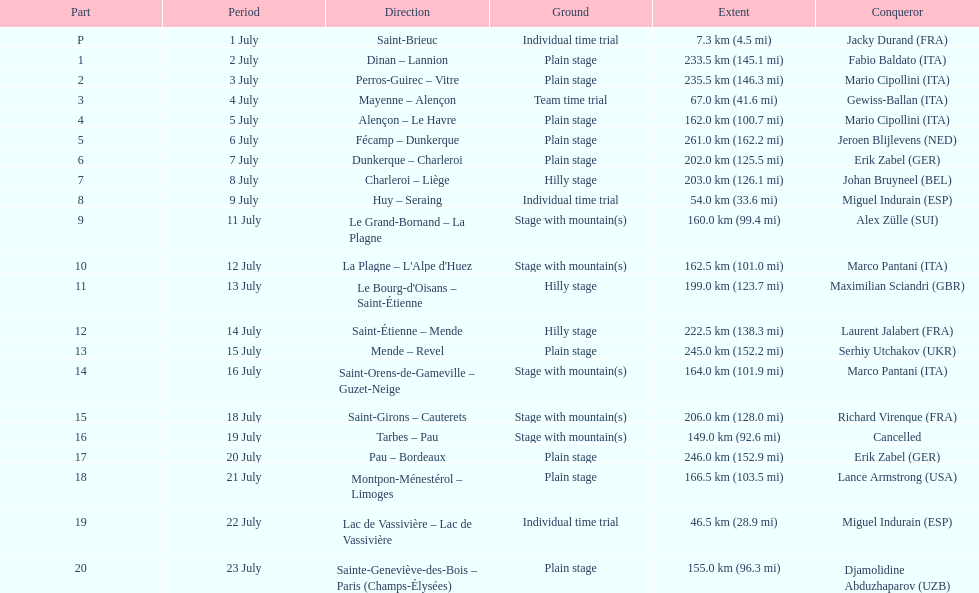Would you mind parsing the complete table? {'header': ['Part', 'Period', 'Direction', 'Ground', 'Extent', 'Conqueror'], 'rows': [['P', '1 July', 'Saint-Brieuc', 'Individual time trial', '7.3\xa0km (4.5\xa0mi)', 'Jacky Durand\xa0(FRA)'], ['1', '2 July', 'Dinan – Lannion', 'Plain stage', '233.5\xa0km (145.1\xa0mi)', 'Fabio Baldato\xa0(ITA)'], ['2', '3 July', 'Perros-Guirec – Vitre', 'Plain stage', '235.5\xa0km (146.3\xa0mi)', 'Mario Cipollini\xa0(ITA)'], ['3', '4 July', 'Mayenne – Alençon', 'Team time trial', '67.0\xa0km (41.6\xa0mi)', 'Gewiss-Ballan\xa0(ITA)'], ['4', '5 July', 'Alençon – Le Havre', 'Plain stage', '162.0\xa0km (100.7\xa0mi)', 'Mario Cipollini\xa0(ITA)'], ['5', '6 July', 'Fécamp – Dunkerque', 'Plain stage', '261.0\xa0km (162.2\xa0mi)', 'Jeroen Blijlevens\xa0(NED)'], ['6', '7 July', 'Dunkerque – Charleroi', 'Plain stage', '202.0\xa0km (125.5\xa0mi)', 'Erik Zabel\xa0(GER)'], ['7', '8 July', 'Charleroi – Liège', 'Hilly stage', '203.0\xa0km (126.1\xa0mi)', 'Johan Bruyneel\xa0(BEL)'], ['8', '9 July', 'Huy – Seraing', 'Individual time trial', '54.0\xa0km (33.6\xa0mi)', 'Miguel Indurain\xa0(ESP)'], ['9', '11 July', 'Le Grand-Bornand – La Plagne', 'Stage with mountain(s)', '160.0\xa0km (99.4\xa0mi)', 'Alex Zülle\xa0(SUI)'], ['10', '12 July', "La Plagne – L'Alpe d'Huez", 'Stage with mountain(s)', '162.5\xa0km (101.0\xa0mi)', 'Marco Pantani\xa0(ITA)'], ['11', '13 July', "Le Bourg-d'Oisans – Saint-Étienne", 'Hilly stage', '199.0\xa0km (123.7\xa0mi)', 'Maximilian Sciandri\xa0(GBR)'], ['12', '14 July', 'Saint-Étienne – Mende', 'Hilly stage', '222.5\xa0km (138.3\xa0mi)', 'Laurent Jalabert\xa0(FRA)'], ['13', '15 July', 'Mende – Revel', 'Plain stage', '245.0\xa0km (152.2\xa0mi)', 'Serhiy Utchakov\xa0(UKR)'], ['14', '16 July', 'Saint-Orens-de-Gameville – Guzet-Neige', 'Stage with mountain(s)', '164.0\xa0km (101.9\xa0mi)', 'Marco Pantani\xa0(ITA)'], ['15', '18 July', 'Saint-Girons – Cauterets', 'Stage with mountain(s)', '206.0\xa0km (128.0\xa0mi)', 'Richard Virenque\xa0(FRA)'], ['16', '19 July', 'Tarbes – Pau', 'Stage with mountain(s)', '149.0\xa0km (92.6\xa0mi)', 'Cancelled'], ['17', '20 July', 'Pau – Bordeaux', 'Plain stage', '246.0\xa0km (152.9\xa0mi)', 'Erik Zabel\xa0(GER)'], ['18', '21 July', 'Montpon-Ménestérol – Limoges', 'Plain stage', '166.5\xa0km (103.5\xa0mi)', 'Lance Armstrong\xa0(USA)'], ['19', '22 July', 'Lac de Vassivière – Lac de Vassivière', 'Individual time trial', '46.5\xa0km (28.9\xa0mi)', 'Miguel Indurain\xa0(ESP)'], ['20', '23 July', 'Sainte-Geneviève-des-Bois – Paris (Champs-Élysées)', 'Plain stage', '155.0\xa0km (96.3\xa0mi)', 'Djamolidine Abduzhaparov\xa0(UZB)']]} What is the difference in length between the 20th and 19th stages of the tour de france? 108.5 km. 